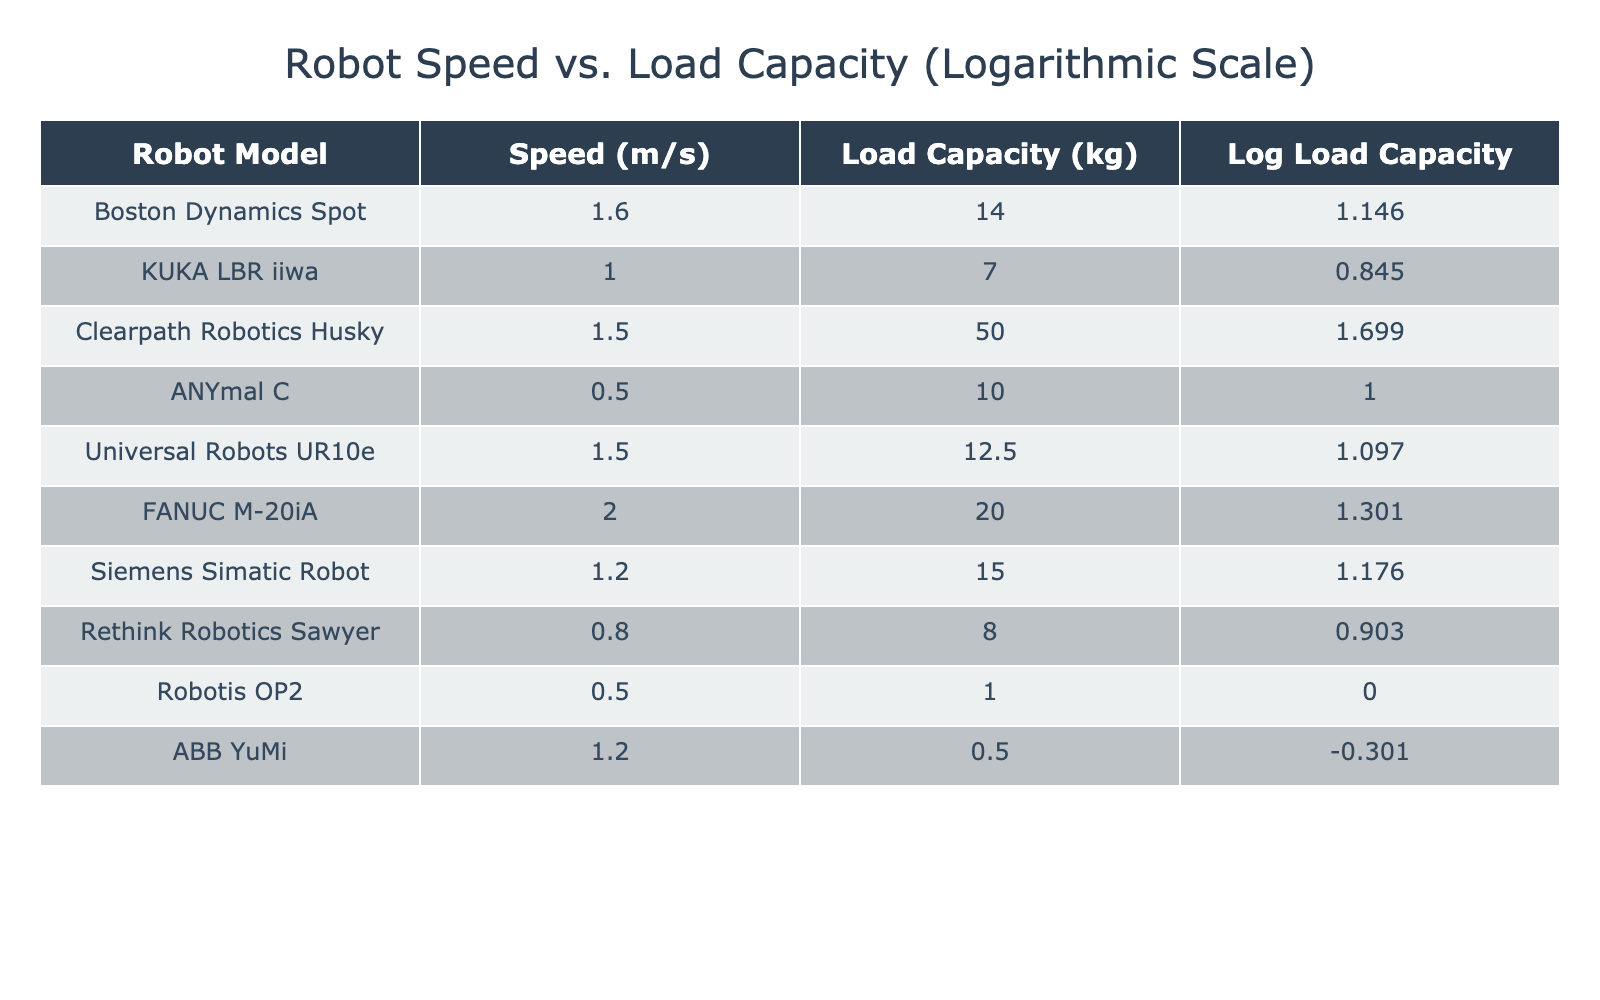What is the speed of the FANUC M-20iA robot? The speed of the FANUC M-20iA robot is listed directly under the "Speed (m/s)" column in the table, which is 2.0 m/s.
Answer: 2.0 m/s Which robot has the highest load capacity? The robot with the highest load capacity can be found by scanning the "Load Capacity (kg)" column for the maximum value. The Clearpath Robotics Husky has the highest load capacity at 50 kg.
Answer: Clearpath Robotics Husky Is the ABB YuMi robot faster than the KUKA LBR iiwa? To answer this, we compare the speeds of both robots listed in the "Speed (m/s)" column. ABB YuMi has a speed of 1.2 m/s, while KUKA LBR iiwa has a speed of 1.0 m/s. Since 1.2 m/s is greater than 1.0 m/s, ABB YuMi is indeed faster.
Answer: Yes What is the average speed of all robots in the table? To find the average speed, we sum all the speeds: 1.6 + 1.0 + 1.5 + 0.5 + 1.5 + 2.0 + 1.2 + 0.8 + 0.5 + 1.2 = 12.8 m/s. There are 10 robots, so we divide 12.8 by 10, which equals 1.28 m/s.
Answer: 1.28 m/s Does any robot have a load capacity greater than 20 kg? We look at the "Load Capacity (kg)" column and check for values greater than 20. The Clearpath Robotics Husky has 50 kg and the FANUC M-20iA has 20 kg, indicating that at least one robot does have a load capacity over 20 kg.
Answer: Yes What is the difference in load capacity between the robot with the highest speed and the robot with the lowest load capacity? The highest speed is 2.0 m/s (FANUC M-20iA, having a load capacity of 20 kg) and the lowest load capacity is 0.5 kg (ABB YuMi). The difference is 20 - 0.5 = 19.5 kg.
Answer: 19.5 kg Which robot had a speed of 0.5 m/s? The table shows that the ANYmal C and Robotis OP2 both have a speed of 0.5 m/s, meaning there are two robots that match this condition.
Answer: ANYmal C and Robotis OP2 What is the median log load capacity among all the robots? First, we list the log load capacities: log(14), log(7), log(50), log(10), log(12.5), log(20), log(15), log(8), log(1), log(0.5). Sorting these values, the median (the middle value) is the average of the 5th and 6th values after sorting, which results in approximately 1.301 (for load capacities 8 and 14) when calculated.
Answer: Approximately 1.301 Is the speed of the Clearpath Robotics Husky greater than that of the ANYmal C? We compare their speeds: Clearpath Robotics Husky has a speed of 1.5 m/s, while ANYmal C has a speed of 0.5 m/s. Since 1.5 m/s is greater than 0.5 m/s, the Clearpath Robotics Husky is indeed faster.
Answer: Yes 